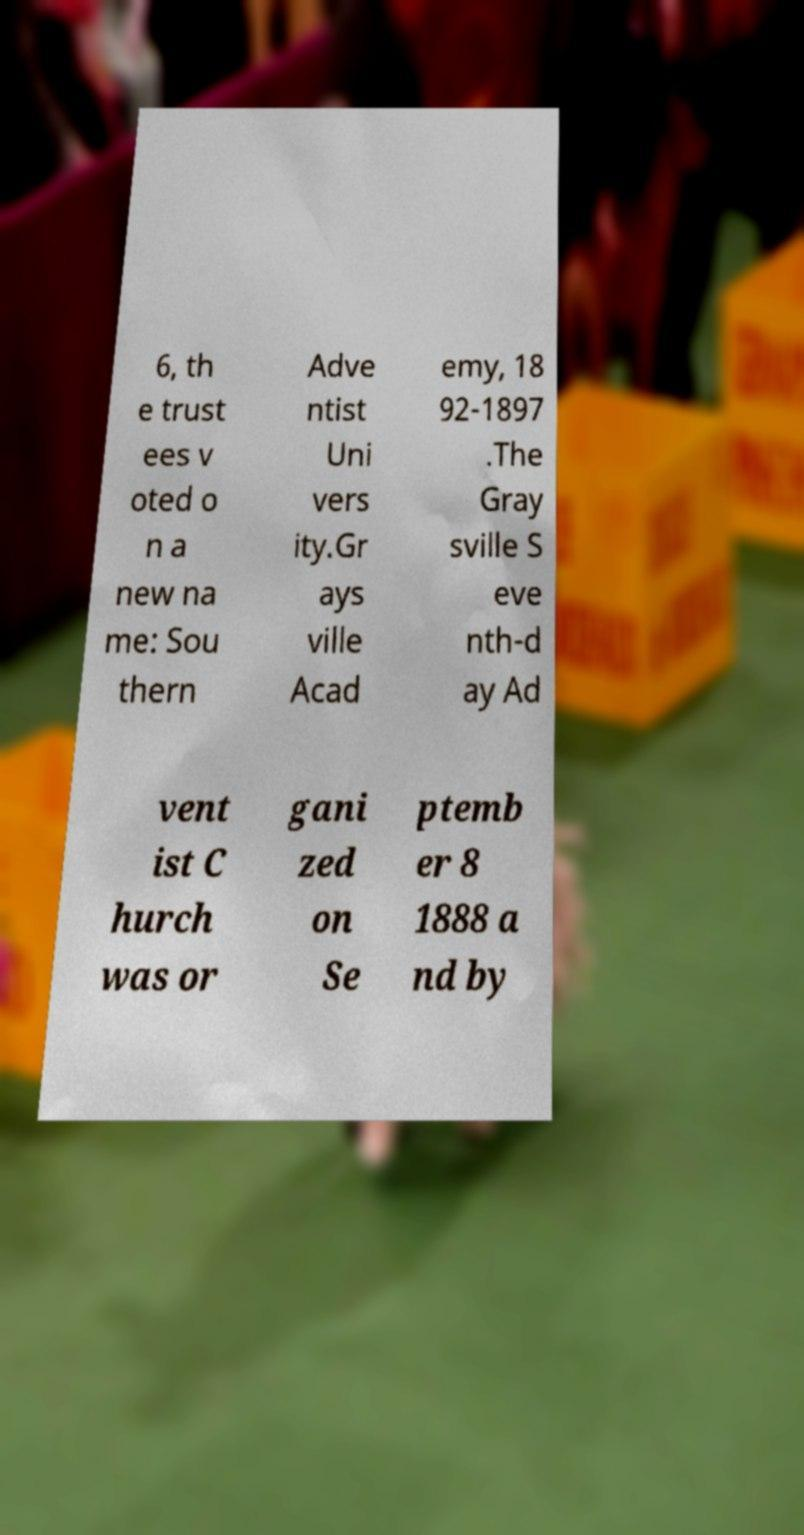Please read and relay the text visible in this image. What does it say? 6, th e trust ees v oted o n a new na me: Sou thern Adve ntist Uni vers ity.Gr ays ville Acad emy, 18 92-1897 .The Gray sville S eve nth-d ay Ad vent ist C hurch was or gani zed on Se ptemb er 8 1888 a nd by 